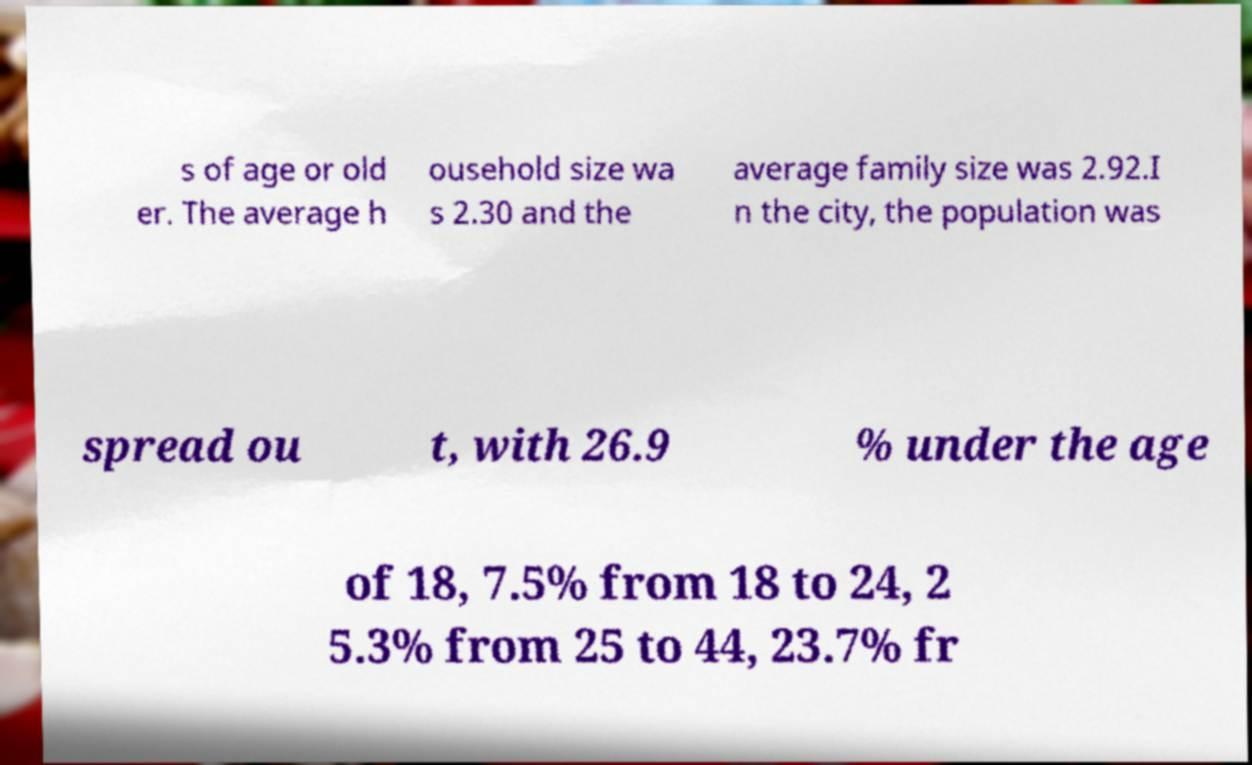Can you read and provide the text displayed in the image?This photo seems to have some interesting text. Can you extract and type it out for me? s of age or old er. The average h ousehold size wa s 2.30 and the average family size was 2.92.I n the city, the population was spread ou t, with 26.9 % under the age of 18, 7.5% from 18 to 24, 2 5.3% from 25 to 44, 23.7% fr 